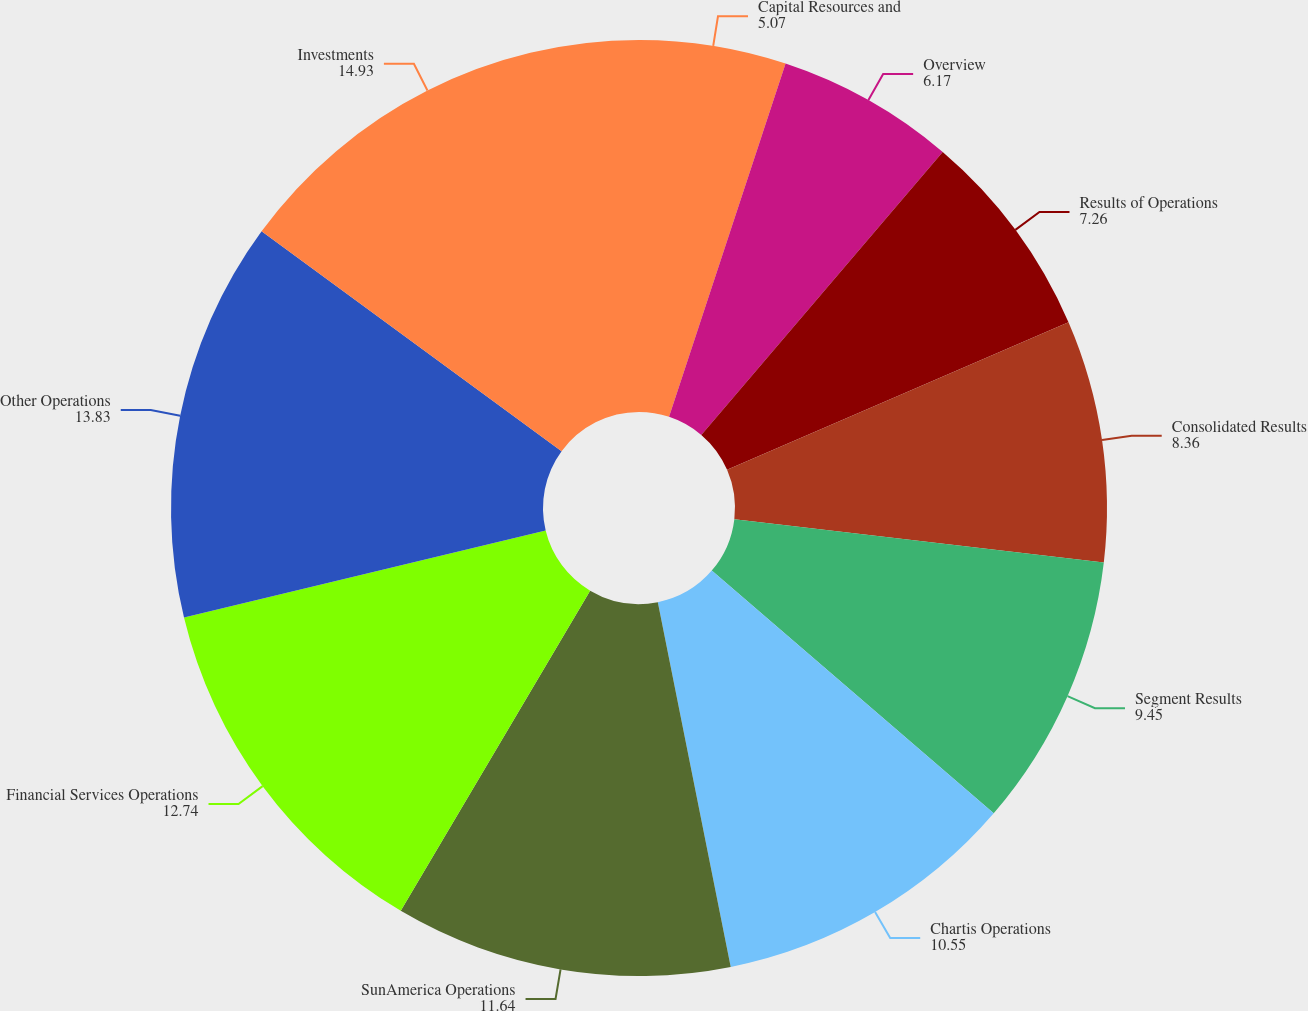<chart> <loc_0><loc_0><loc_500><loc_500><pie_chart><fcel>Capital Resources and<fcel>Overview<fcel>Results of Operations<fcel>Consolidated Results<fcel>Segment Results<fcel>Chartis Operations<fcel>SunAmerica Operations<fcel>Financial Services Operations<fcel>Other Operations<fcel>Investments<nl><fcel>5.07%<fcel>6.17%<fcel>7.26%<fcel>8.36%<fcel>9.45%<fcel>10.55%<fcel>11.64%<fcel>12.74%<fcel>13.83%<fcel>14.93%<nl></chart> 